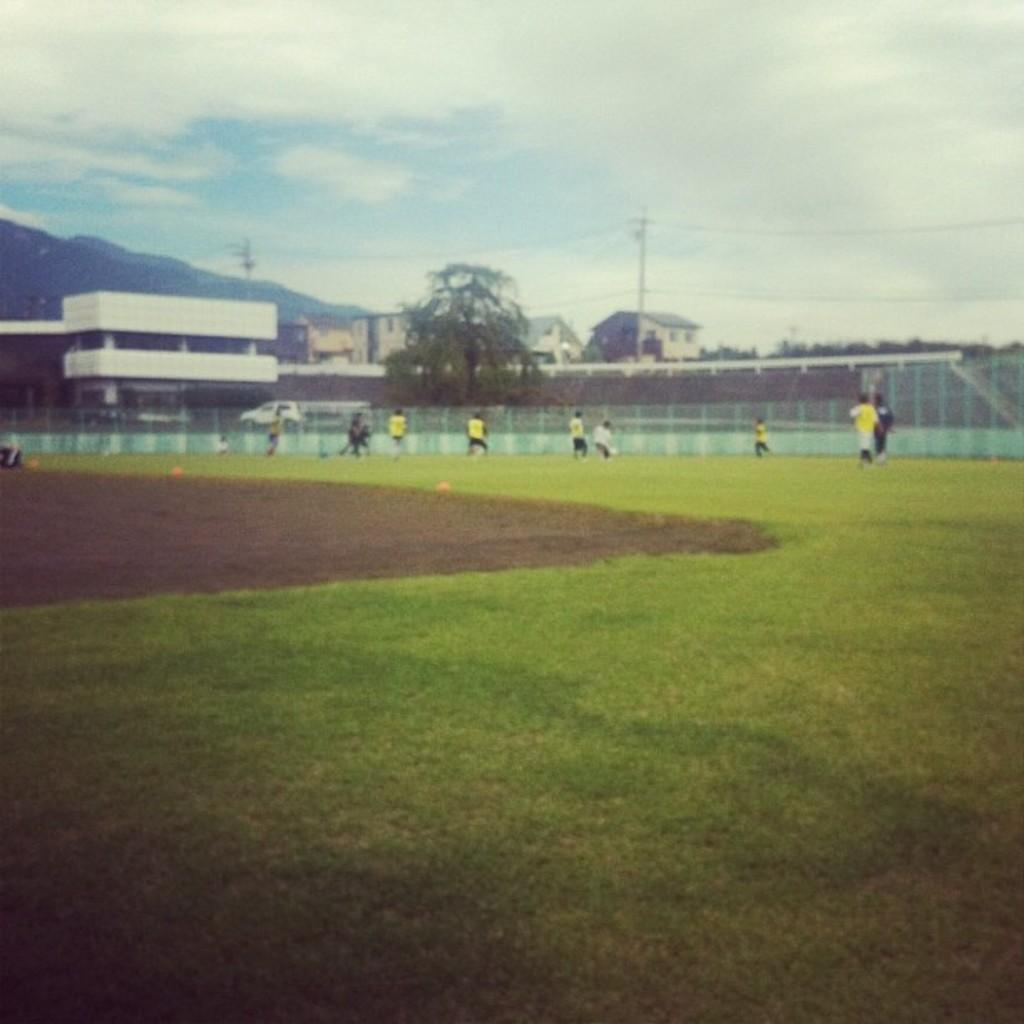What are the people in the image doing? The people in the image are playing in the ground. What structures can be seen in the image? There are buildings and poles in the image. What natural features are present in the background? There are mountains and trees in the image. What object is used for separating the playing area? There is a net in the image. What can be seen in the sky in the background? The sky with clouds is visible in the background. What type of cow can be seen grazing in the image? There is no cow present in the image. What story is being told by the people playing in the image? The image does not depict a story being told; it shows people playing. 